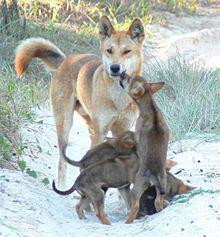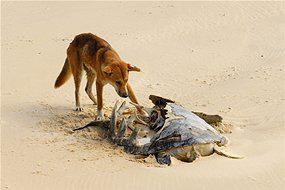The first image is the image on the left, the second image is the image on the right. Evaluate the accuracy of this statement regarding the images: "The dingo's body in the left image is facing towards the left.". Is it true? Answer yes or no. No. The first image is the image on the left, the second image is the image on the right. Evaluate the accuracy of this statement regarding the images: "A dog is at the left of an image, standing behind a dead animal washed up on a beach.". Is it true? Answer yes or no. Yes. 